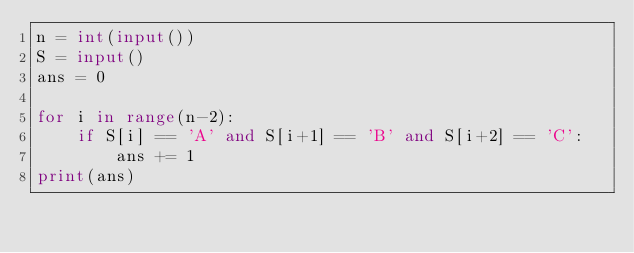<code> <loc_0><loc_0><loc_500><loc_500><_Python_>n = int(input())
S = input()
ans = 0

for i in range(n-2):
    if S[i] == 'A' and S[i+1] == 'B' and S[i+2] == 'C':
        ans += 1
print(ans)</code> 